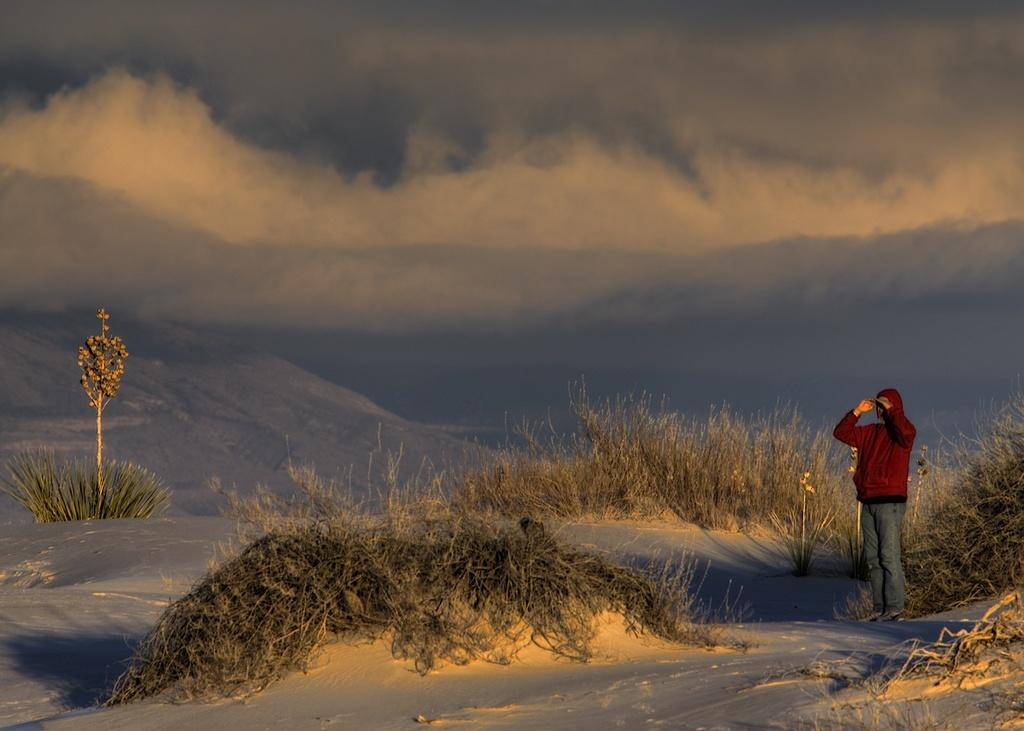What is the main subject in the image? There is a person standing in the image. What else can be seen in the image besides the person? Planets and the sky are visible in the image. How many times does the tramp sneeze in the image? There is no tramp or sneezing present in the image. 